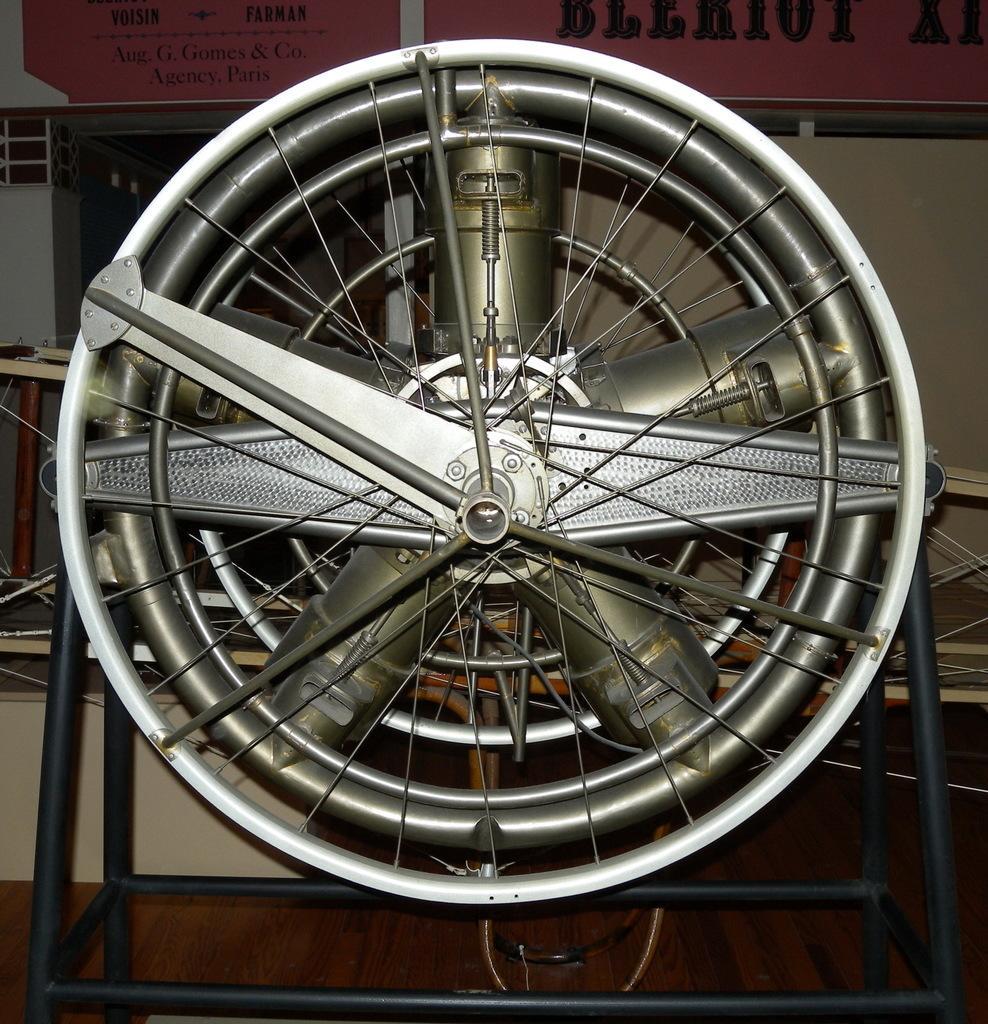In one or two sentences, can you explain what this image depicts? The picture consists of an electric fan, placed on a wooden desk. In the background there are desk ,mechanical objects and wall. 